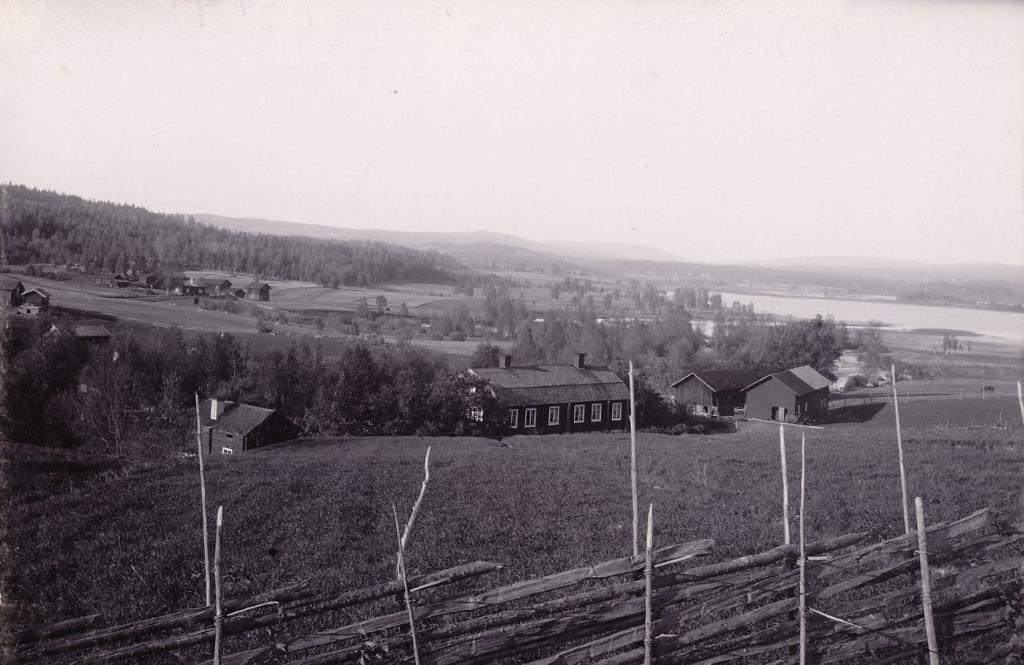What type of natural elements can be seen in the image? There are trees in the image. What type of man-made structures are present in the image? There are houses in the image. What type of geographical features can be seen in the image? There are hills in the image. What is visible in the background of the image? The sky is visible in the background of the image. Where is the mark on the book in the image? There is no book or mark present in the image. What type of jewelry is the person wearing in the image? There is no person or locket present in the image. 